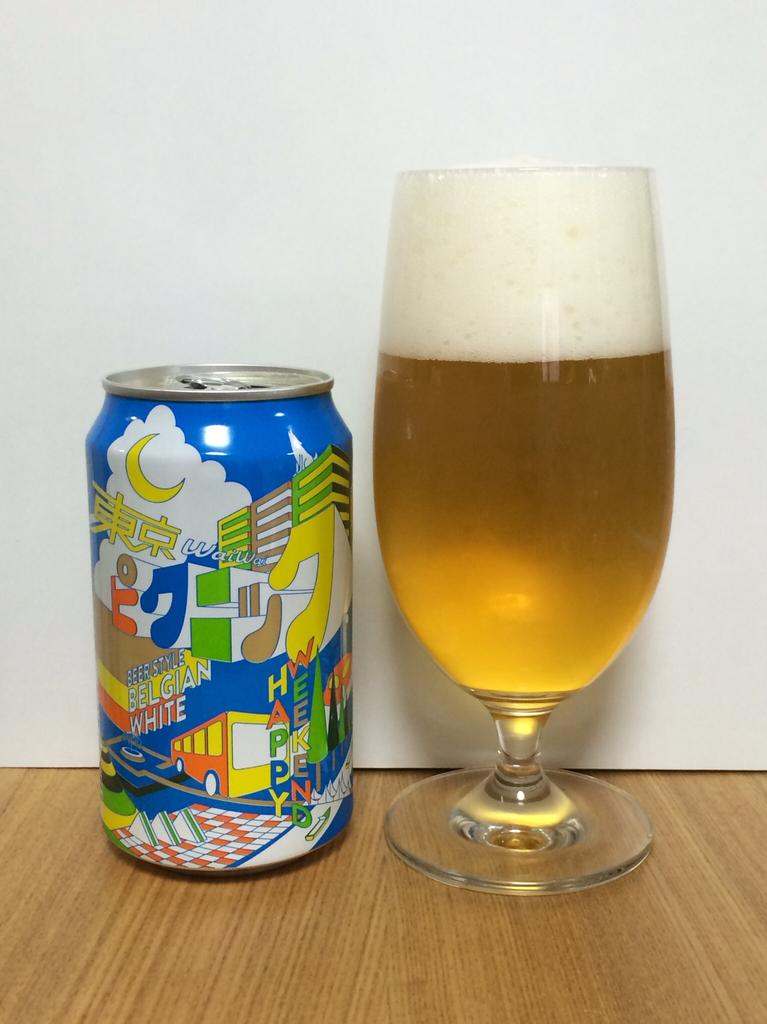What is in the glass that is visible in the image? There is a drink in the glass. What other object can be seen in the image besides the glass? There is a tin visible in the image. Where are the glass and tin located in the image? Both the glass and tin are placed on a table. What type of education can be seen taking place in the image? There is no indication of any educational activity in the image; it features a glass with a drink and a tin on a table. What is the top of the tin like in the image? The provided facts do not mention any details about the top of the tin, so we cannot answer this question. 